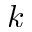<formula> <loc_0><loc_0><loc_500><loc_500>k</formula> 